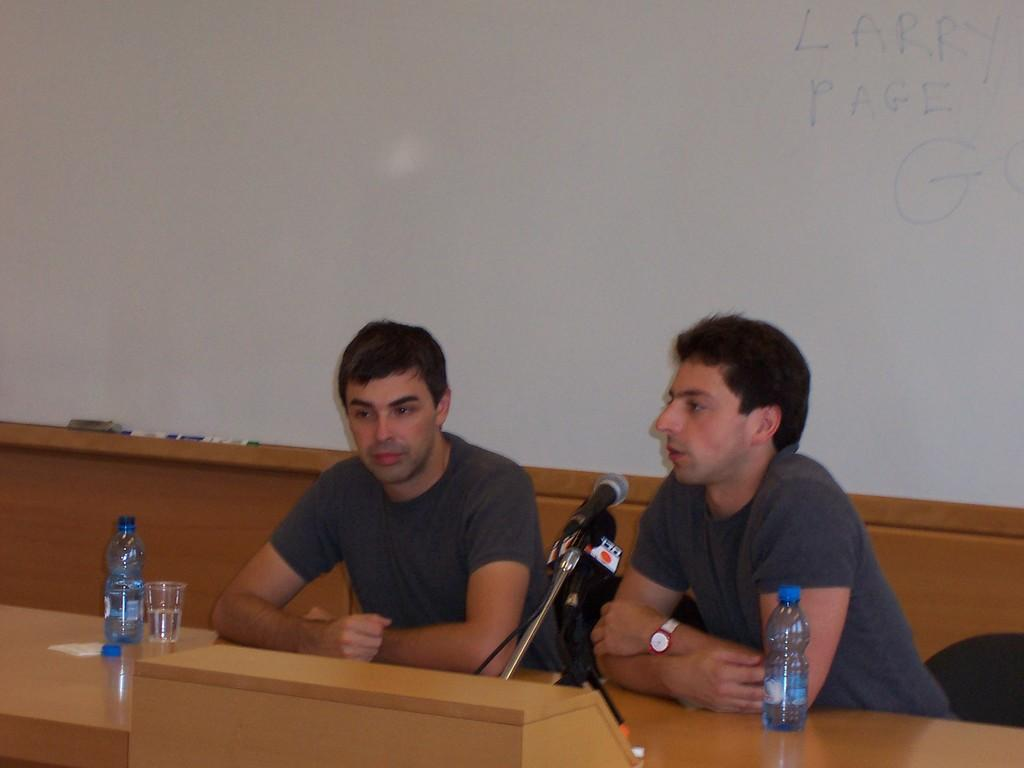How many people are in the image? There are two men in the image. What are the men doing in the image? The men are sitting on a bench. What objects can be seen on the table in the image? There is a glass, a bottle, a paper, and a microphone on the table. What can be found in the background of the image? There are markers and a grey object in the background. How many cows are visible in the image? There are no cows present in the image. What type of engine can be seen on the table? There is no engine present in the image; the objects on the table include a glass, a bottle, a paper, and a microphone. 